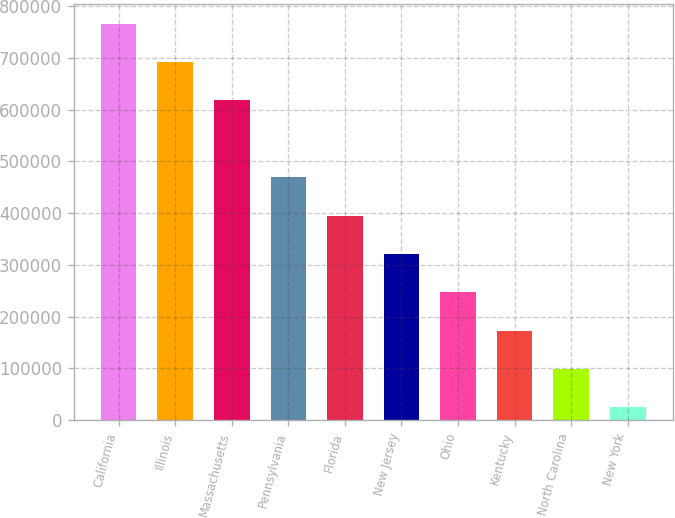Convert chart. <chart><loc_0><loc_0><loc_500><loc_500><bar_chart><fcel>California<fcel>Illinois<fcel>Massachusetts<fcel>Pennsylvania<fcel>Florida<fcel>New Jersey<fcel>Ohio<fcel>Kentucky<fcel>North Carolina<fcel>New York<nl><fcel>766211<fcel>692056<fcel>617901<fcel>469591<fcel>395436<fcel>321282<fcel>247127<fcel>172972<fcel>98816.9<fcel>24662<nl></chart> 